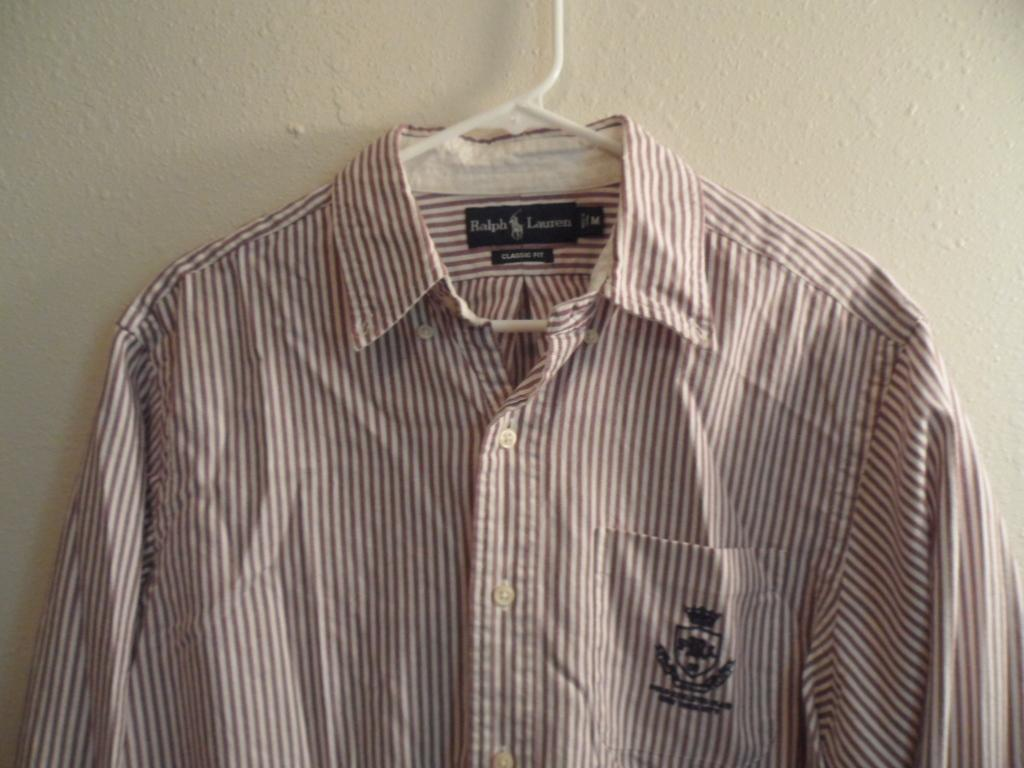What type of clothing item is in the image? There is a shirt in the image. What colors are featured on the shirt? The shirt is white and maroon in color. Where is the shirt located in the image? The shirt is hanged on a wall. What color is the wall on which the shirt is hung? The wall is cream colored. What is used to hang the shirt on the wall? There is a hanger in the image. What color is the hanger? The hanger is white in color. Can you see any ants crawling on the shirt in the image? There are no ants present in the image. What type of tramp is located downtown in the image? There is no tramp or downtown location mentioned in the image; it only features a shirt, a wall, and a hanger. 